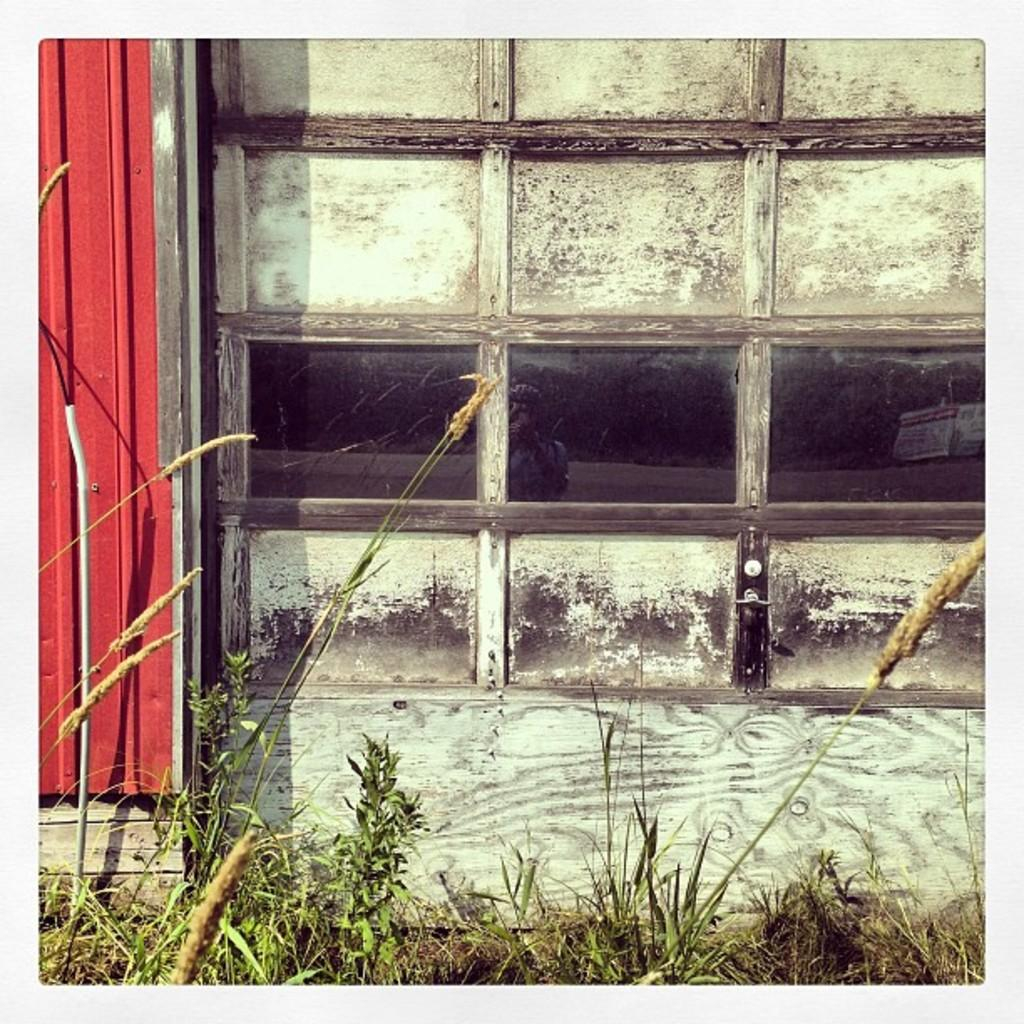What type of material is used for the wall in the center of the image? There is a wooden wall in the center of the image. What is the glass used for in the image? The glass is not specified for a particular use in the image. What color is the sheet in the image? The sheet in the image is red. What is the door made of in the image? There is a wooden door in the image. What type of natural environment is visible in the image? There is grass visible in the image. How many ladybugs can be seen crawling on the wooden wall in the image? There are no ladybugs present in the image. What type of sea creature can be seen swimming in the grass in the image? There are no sea creatures present in the image, as it features grass and not a body of water. 